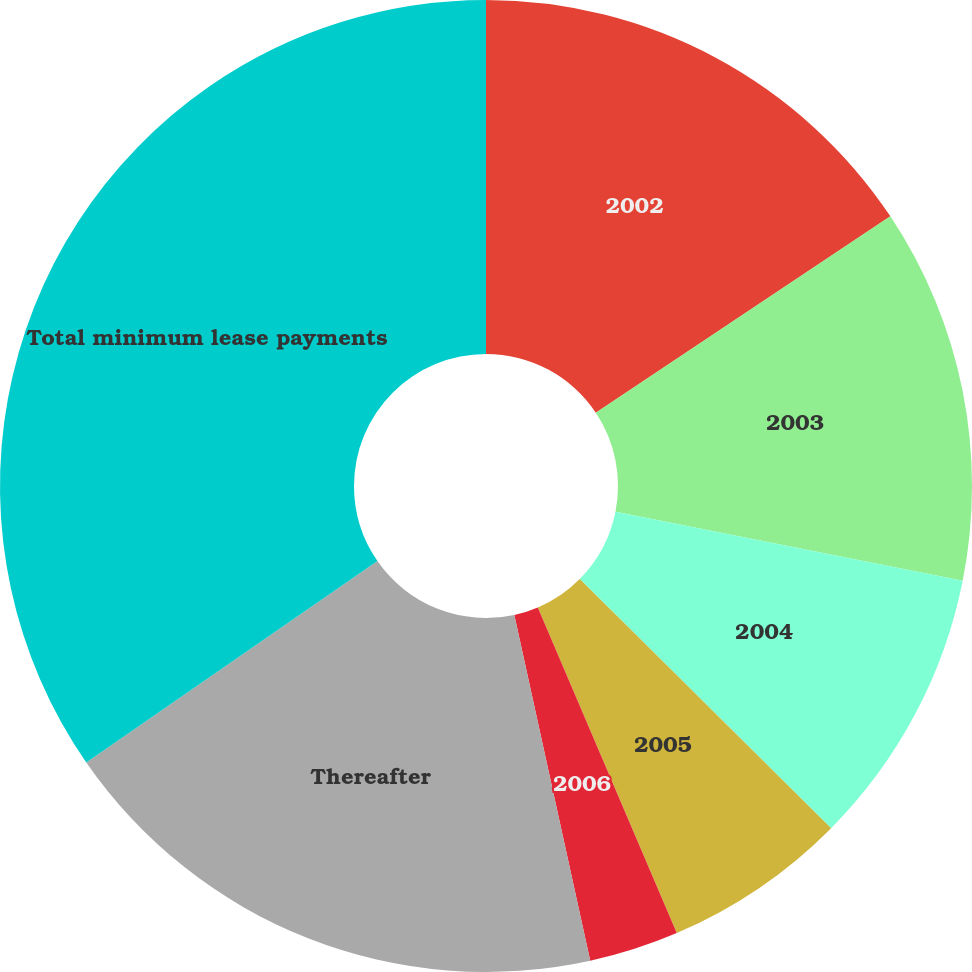<chart> <loc_0><loc_0><loc_500><loc_500><pie_chart><fcel>2002<fcel>2003<fcel>2004<fcel>2005<fcel>2006<fcel>Thereafter<fcel>Total minimum lease payments<nl><fcel>15.64%<fcel>12.48%<fcel>9.31%<fcel>6.15%<fcel>2.98%<fcel>18.81%<fcel>34.63%<nl></chart> 